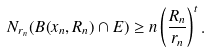Convert formula to latex. <formula><loc_0><loc_0><loc_500><loc_500>N _ { r _ { n } } ( B ( x _ { n } , R _ { n } ) \cap E ) \geq n \left ( \frac { R _ { n } } { r _ { n } } \right ) ^ { t } .</formula> 